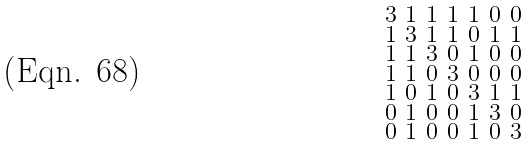<formula> <loc_0><loc_0><loc_500><loc_500>\begin{smallmatrix} 3 & 1 & 1 & 1 & 1 & 0 & 0 \\ 1 & 3 & 1 & 1 & 0 & 1 & 1 \\ 1 & 1 & 3 & 0 & 1 & 0 & 0 \\ 1 & 1 & 0 & 3 & 0 & 0 & 0 \\ 1 & 0 & 1 & 0 & 3 & 1 & 1 \\ 0 & 1 & 0 & 0 & 1 & 3 & 0 \\ 0 & 1 & 0 & 0 & 1 & 0 & 3 \end{smallmatrix}</formula> 